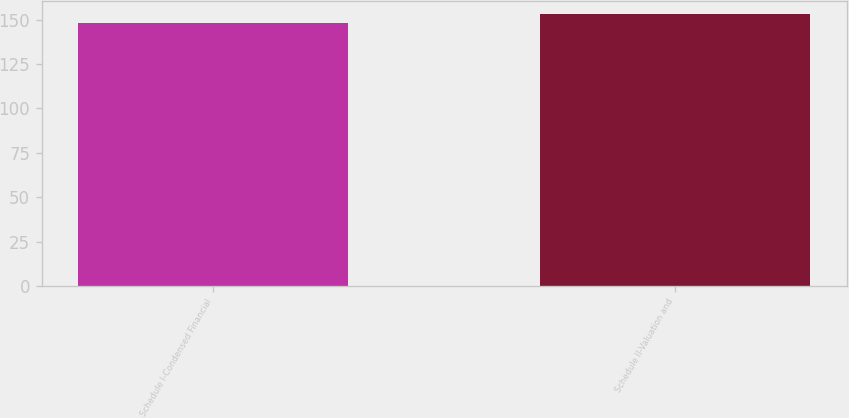Convert chart. <chart><loc_0><loc_0><loc_500><loc_500><bar_chart><fcel>Schedule I-Condensed Financial<fcel>Schedule II-Valuation and<nl><fcel>148<fcel>153<nl></chart> 